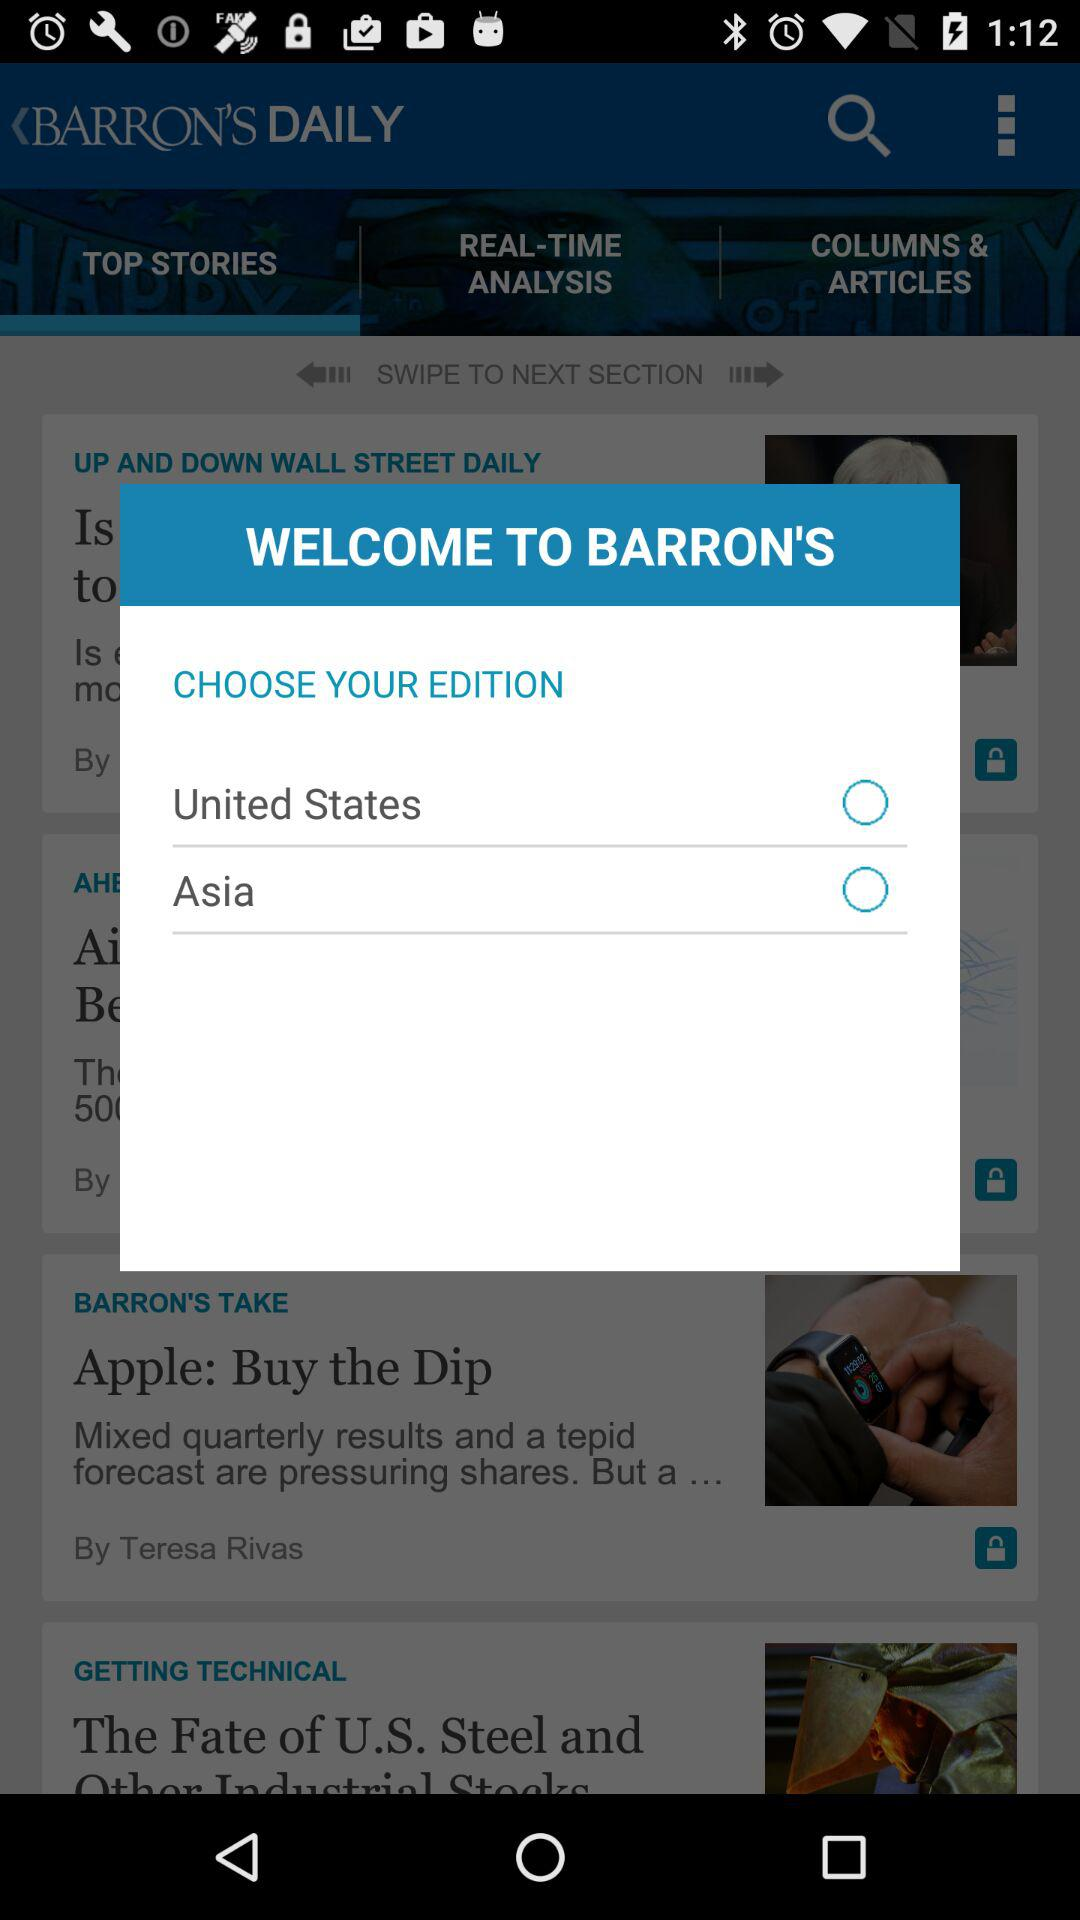What options are there for "CHOOSE YOUR EDITION"? The options for "CHOOSE YOUR EDITION" are "United States" and "Asia". 